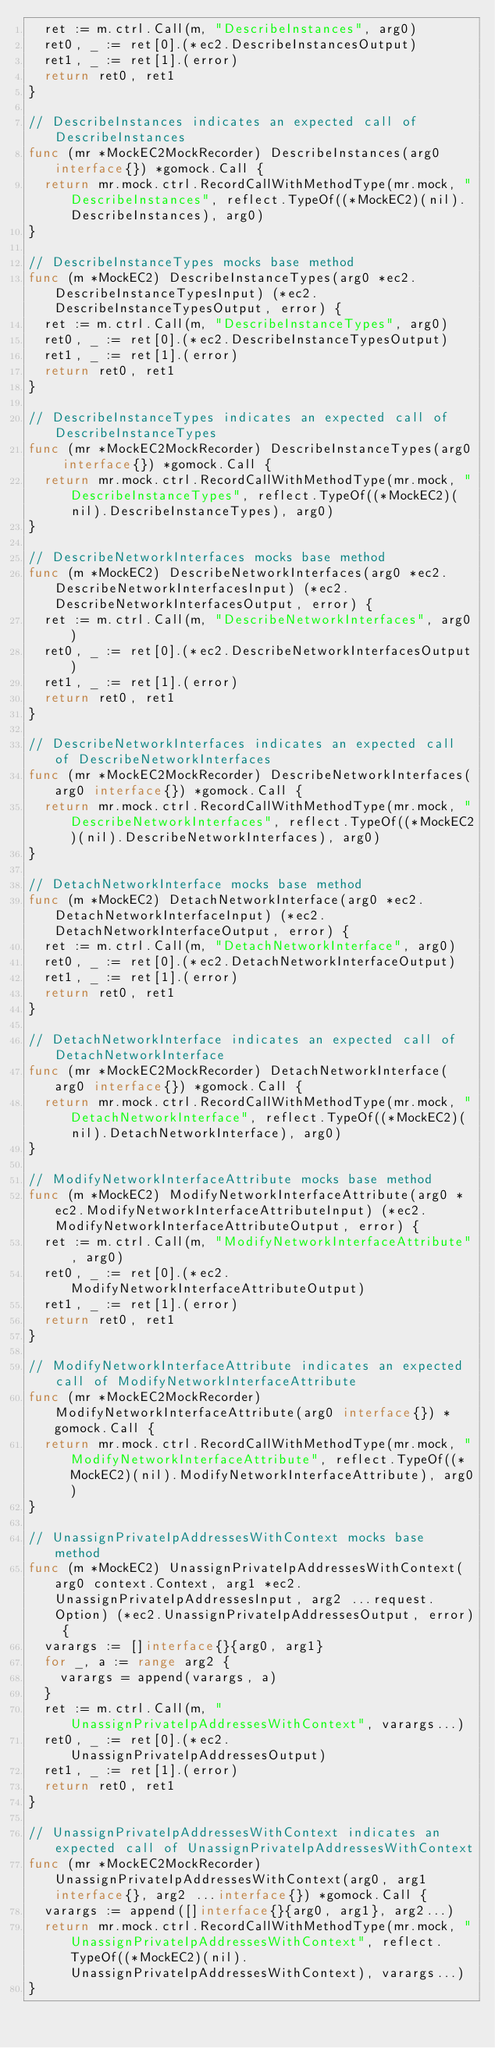<code> <loc_0><loc_0><loc_500><loc_500><_Go_>	ret := m.ctrl.Call(m, "DescribeInstances", arg0)
	ret0, _ := ret[0].(*ec2.DescribeInstancesOutput)
	ret1, _ := ret[1].(error)
	return ret0, ret1
}

// DescribeInstances indicates an expected call of DescribeInstances
func (mr *MockEC2MockRecorder) DescribeInstances(arg0 interface{}) *gomock.Call {
	return mr.mock.ctrl.RecordCallWithMethodType(mr.mock, "DescribeInstances", reflect.TypeOf((*MockEC2)(nil).DescribeInstances), arg0)
}

// DescribeInstanceTypes mocks base method
func (m *MockEC2) DescribeInstanceTypes(arg0 *ec2.DescribeInstanceTypesInput) (*ec2.DescribeInstanceTypesOutput, error) {
	ret := m.ctrl.Call(m, "DescribeInstanceTypes", arg0)
	ret0, _ := ret[0].(*ec2.DescribeInstanceTypesOutput)
	ret1, _ := ret[1].(error)
	return ret0, ret1
}

// DescribeInstanceTypes indicates an expected call of DescribeInstanceTypes
func (mr *MockEC2MockRecorder) DescribeInstanceTypes(arg0 interface{}) *gomock.Call {
	return mr.mock.ctrl.RecordCallWithMethodType(mr.mock, "DescribeInstanceTypes", reflect.TypeOf((*MockEC2)(nil).DescribeInstanceTypes), arg0)
}

// DescribeNetworkInterfaces mocks base method
func (m *MockEC2) DescribeNetworkInterfaces(arg0 *ec2.DescribeNetworkInterfacesInput) (*ec2.DescribeNetworkInterfacesOutput, error) {
	ret := m.ctrl.Call(m, "DescribeNetworkInterfaces", arg0)
	ret0, _ := ret[0].(*ec2.DescribeNetworkInterfacesOutput)
	ret1, _ := ret[1].(error)
	return ret0, ret1
}

// DescribeNetworkInterfaces indicates an expected call of DescribeNetworkInterfaces
func (mr *MockEC2MockRecorder) DescribeNetworkInterfaces(arg0 interface{}) *gomock.Call {
	return mr.mock.ctrl.RecordCallWithMethodType(mr.mock, "DescribeNetworkInterfaces", reflect.TypeOf((*MockEC2)(nil).DescribeNetworkInterfaces), arg0)
}

// DetachNetworkInterface mocks base method
func (m *MockEC2) DetachNetworkInterface(arg0 *ec2.DetachNetworkInterfaceInput) (*ec2.DetachNetworkInterfaceOutput, error) {
	ret := m.ctrl.Call(m, "DetachNetworkInterface", arg0)
	ret0, _ := ret[0].(*ec2.DetachNetworkInterfaceOutput)
	ret1, _ := ret[1].(error)
	return ret0, ret1
}

// DetachNetworkInterface indicates an expected call of DetachNetworkInterface
func (mr *MockEC2MockRecorder) DetachNetworkInterface(arg0 interface{}) *gomock.Call {
	return mr.mock.ctrl.RecordCallWithMethodType(mr.mock, "DetachNetworkInterface", reflect.TypeOf((*MockEC2)(nil).DetachNetworkInterface), arg0)
}

// ModifyNetworkInterfaceAttribute mocks base method
func (m *MockEC2) ModifyNetworkInterfaceAttribute(arg0 *ec2.ModifyNetworkInterfaceAttributeInput) (*ec2.ModifyNetworkInterfaceAttributeOutput, error) {
	ret := m.ctrl.Call(m, "ModifyNetworkInterfaceAttribute", arg0)
	ret0, _ := ret[0].(*ec2.ModifyNetworkInterfaceAttributeOutput)
	ret1, _ := ret[1].(error)
	return ret0, ret1
}

// ModifyNetworkInterfaceAttribute indicates an expected call of ModifyNetworkInterfaceAttribute
func (mr *MockEC2MockRecorder) ModifyNetworkInterfaceAttribute(arg0 interface{}) *gomock.Call {
	return mr.mock.ctrl.RecordCallWithMethodType(mr.mock, "ModifyNetworkInterfaceAttribute", reflect.TypeOf((*MockEC2)(nil).ModifyNetworkInterfaceAttribute), arg0)
}

// UnassignPrivateIpAddressesWithContext mocks base method
func (m *MockEC2) UnassignPrivateIpAddressesWithContext(arg0 context.Context, arg1 *ec2.UnassignPrivateIpAddressesInput, arg2 ...request.Option) (*ec2.UnassignPrivateIpAddressesOutput, error) {
	varargs := []interface{}{arg0, arg1}
	for _, a := range arg2 {
		varargs = append(varargs, a)
	}
	ret := m.ctrl.Call(m, "UnassignPrivateIpAddressesWithContext", varargs...)
	ret0, _ := ret[0].(*ec2.UnassignPrivateIpAddressesOutput)
	ret1, _ := ret[1].(error)
	return ret0, ret1
}

// UnassignPrivateIpAddressesWithContext indicates an expected call of UnassignPrivateIpAddressesWithContext
func (mr *MockEC2MockRecorder) UnassignPrivateIpAddressesWithContext(arg0, arg1 interface{}, arg2 ...interface{}) *gomock.Call {
	varargs := append([]interface{}{arg0, arg1}, arg2...)
	return mr.mock.ctrl.RecordCallWithMethodType(mr.mock, "UnassignPrivateIpAddressesWithContext", reflect.TypeOf((*MockEC2)(nil).UnassignPrivateIpAddressesWithContext), varargs...)
}
</code> 